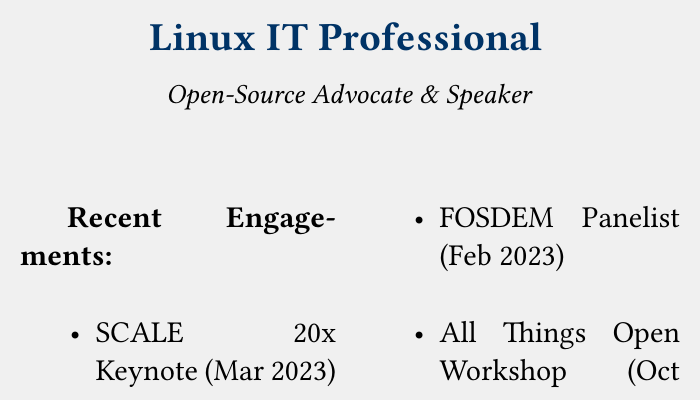what is the title of the document? The title reflects the role of the individual, which is "Linux IT Professional."
Answer: Linux IT Professional what type of professional ethos does this individual advocate? The document mentions the individual's advocacy for a specific philosophy in IT, reflected immediately under the title.
Answer: Open-Source when was the SCALE 20x Keynote event? The date of the event listed is "Mar 2023."
Answer: Mar 2023 what was the role of the individual at the FOSDEM event? The document specifies the individual's participation as a panelist.
Answer: Panelist how many events are listed under Recent Engagements? To get this, we can count the items under the section titled "Recent Engagements." There are four listed events.
Answer: 4 which workshop did the individual participate in during October 2022? The specific workshop mentioned for that date is "All Things Open Workshop."
Answer: All Things Open Workshop what is one area of expertise highlighted in the document? The document lists several expertise areas, one of which is "Linux Administration."
Answer: Linux Administration which event took place in June 2022? The document provides a description of the event that occurred during this month, specifically mentioning the Linux Foundation Summit.
Answer: Linux Foundation Summit what color is used for the title text in the document? The hex code for the title color is specified in the document; the answer can be found by noting the resource used for this color.
Answer: darkblue 